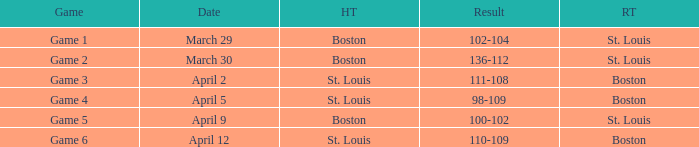What is the Result of the Game on April 9? 100-102. 